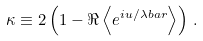<formula> <loc_0><loc_0><loc_500><loc_500>\kappa \equiv 2 \left ( 1 - \Re \left \langle e ^ { i u / \lambda b a r } \right \rangle \right ) \, .</formula> 